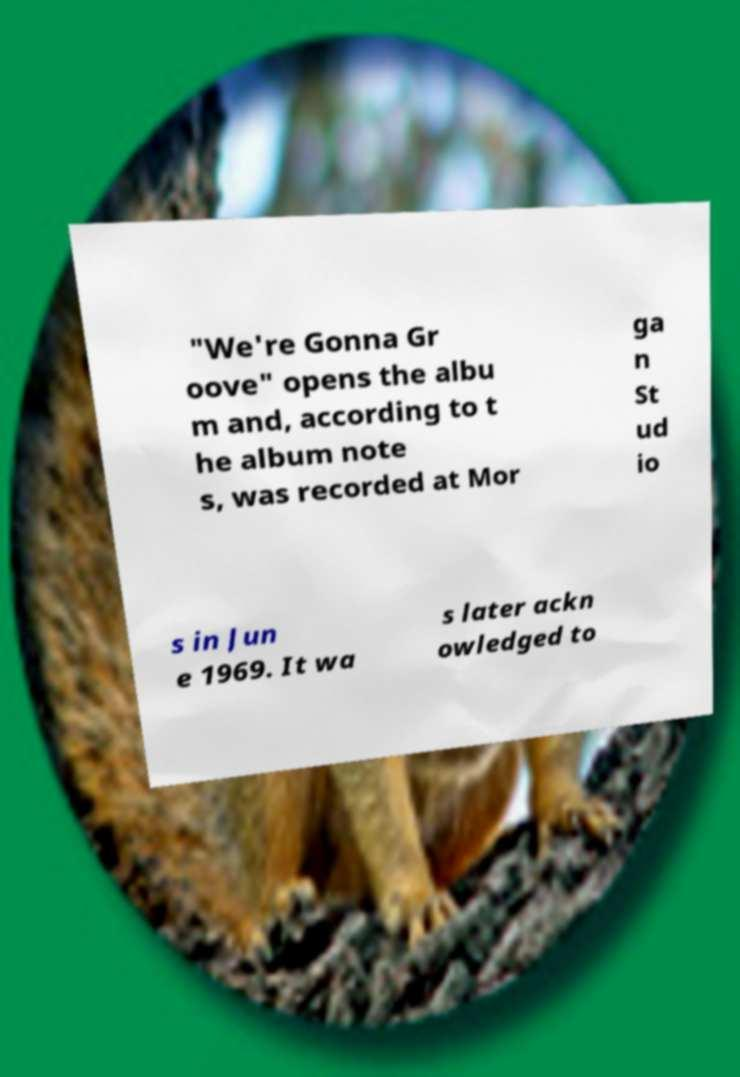What messages or text are displayed in this image? I need them in a readable, typed format. "We're Gonna Gr oove" opens the albu m and, according to t he album note s, was recorded at Mor ga n St ud io s in Jun e 1969. It wa s later ackn owledged to 